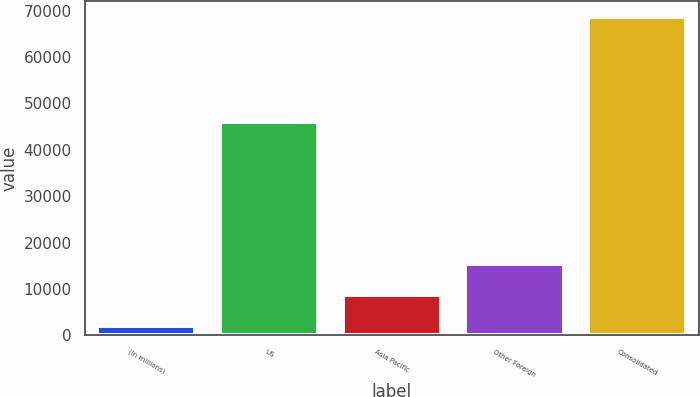Convert chart to OTSL. <chart><loc_0><loc_0><loc_500><loc_500><bar_chart><fcel>(in millions)<fcel>US<fcel>Asia Pacific<fcel>Other Foreign<fcel>Consolidated<nl><fcel>2013<fcel>46031<fcel>8742<fcel>15408.5<fcel>68678<nl></chart> 